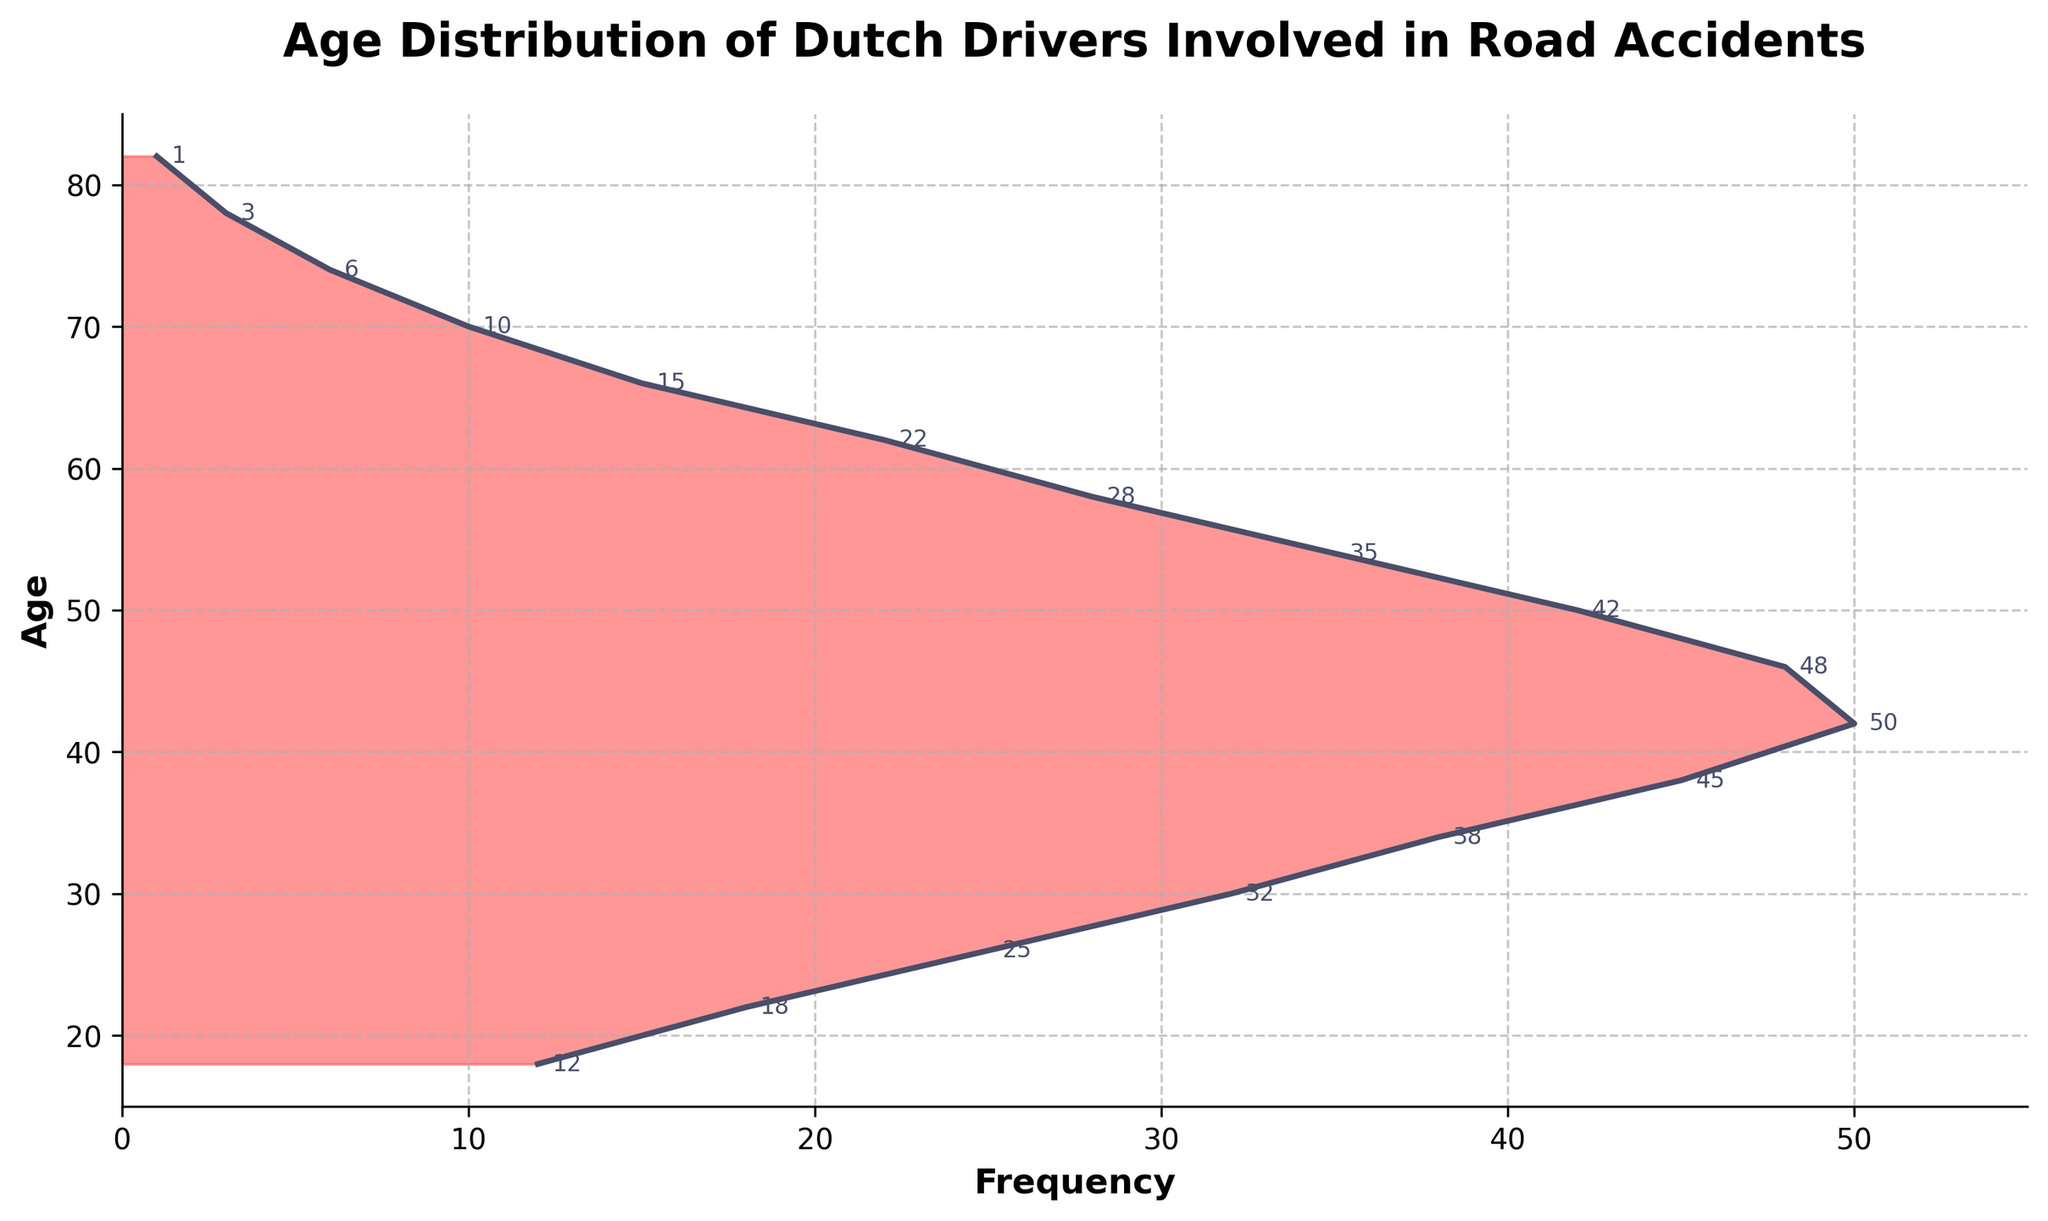What is the title of the plot? The title is written at the top of the plot. It reads "Age Distribution of Dutch Drivers Involved in Road Accidents".
Answer: Age Distribution of Dutch Drivers Involved in Road Accidents What is the highest frequency recorded, and at what age does it occur? By looking at the highest point on the x-axis, we see that the maximum frequency is around 50, and this occurs at the age of 42.
Answer: 50, age 42 How many age groups have a frequency greater than or equal to 30? By scanning the plot, we identify the age groups with frequencies ≥ 30: 26, 30, 34, 38, 42, and 46. This gives us 6 age groups.
Answer: 6 What is the difference in frequency between the age groups of 42 and 58? The frequency at age 42 is 50, while at age 58 it is 28. The difference is calculated as 50 - 28.
Answer: 22 Which age group shows the lowest frequency, and what is the value? The point on the far left of the plot corresponds to the lowest frequency, which is 1 at age 82.
Answer: age 82, frequency 1 Compare the frequencies of ages 30 and 54. Which is higher and by how much? The frequency for age 30 is 32, and for age 54 is 35. The difference is 35 - 32.
Answer: age 54 is higher by 3 How does the frequency change from age 18 to age 22? At age 18, the frequency is 12, and at age 22, it is 18. The frequency increases by 6.
Answer: increases by 6 At what age does the frequency start to decline after reaching its peak? The peak frequency is at age 42. The next data point after 42 is age 46 with a frequency of 48, which is lower than 50.
Answer: age 46 What is the average frequency of accidents for the age groups between 50 and 70 inclusive? The frequencies for ages 50, 54, 58, 62, 66, and 70 are 42, 35, 28, 22, 15, and 10 respectively. The sum is 42 + 35 + 28 + 22 + 15 + 10 = 152. The number of points is 6. The average is 152/6.
Answer: 25.33 